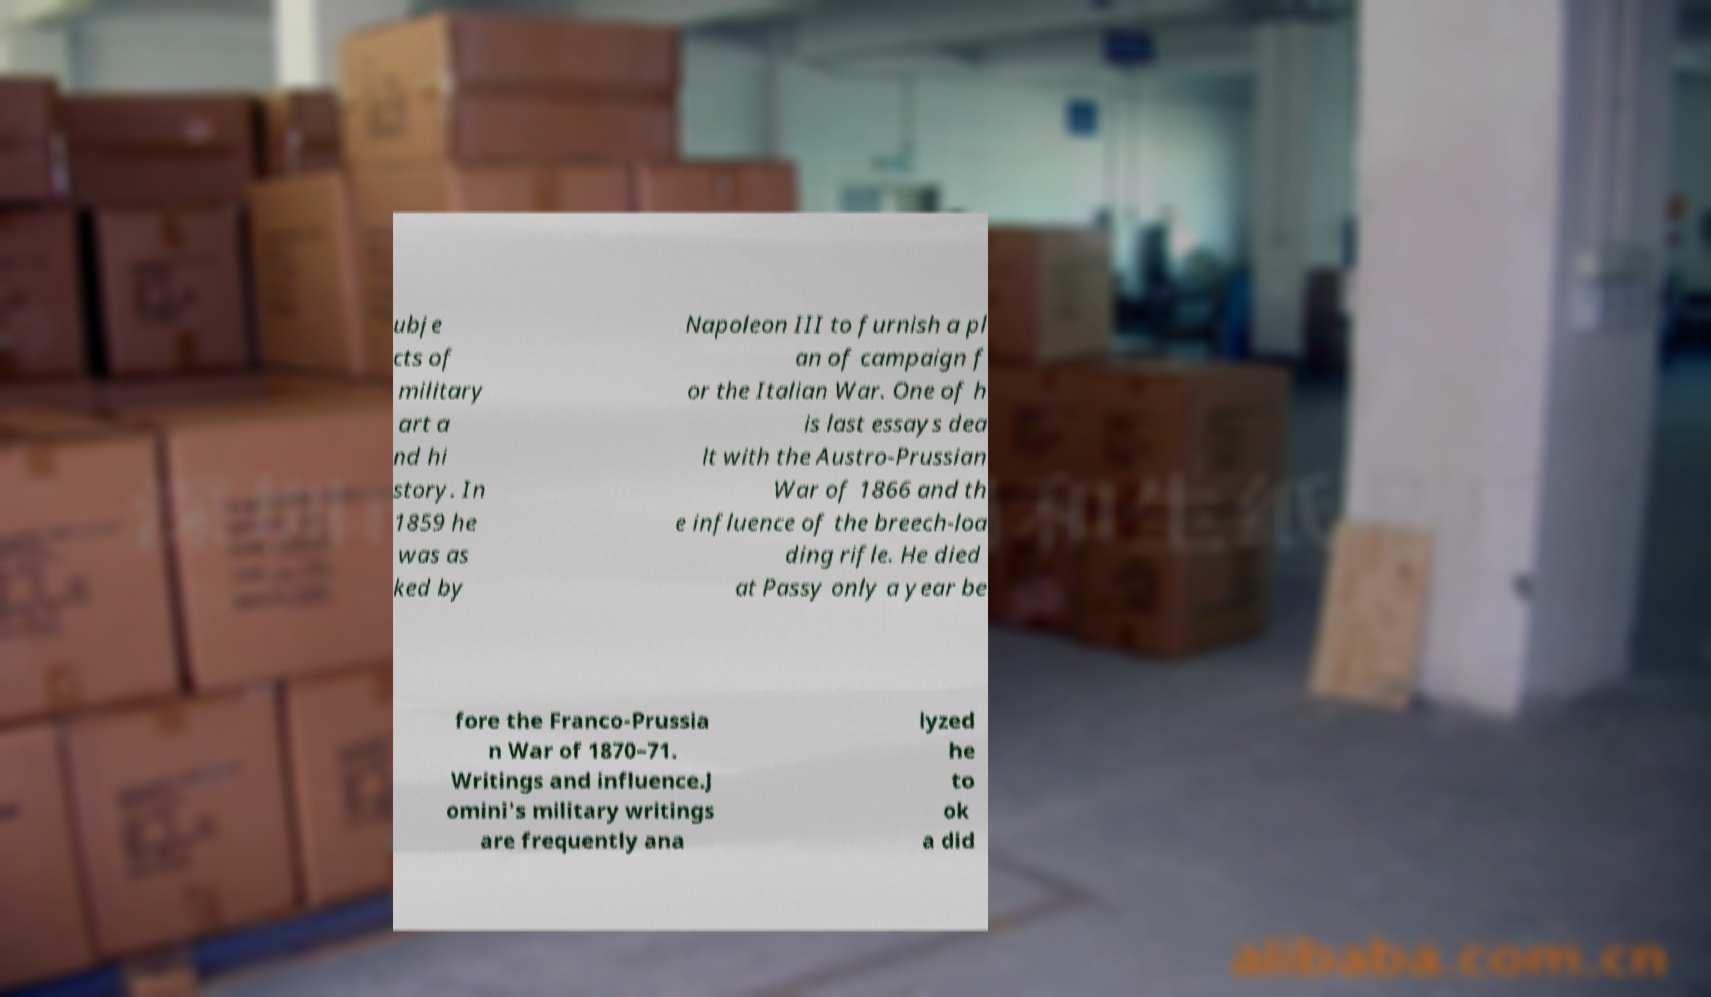I need the written content from this picture converted into text. Can you do that? ubje cts of military art a nd hi story. In 1859 he was as ked by Napoleon III to furnish a pl an of campaign f or the Italian War. One of h is last essays dea lt with the Austro-Prussian War of 1866 and th e influence of the breech-loa ding rifle. He died at Passy only a year be fore the Franco-Prussia n War of 1870–71. Writings and influence.J omini's military writings are frequently ana lyzed he to ok a did 